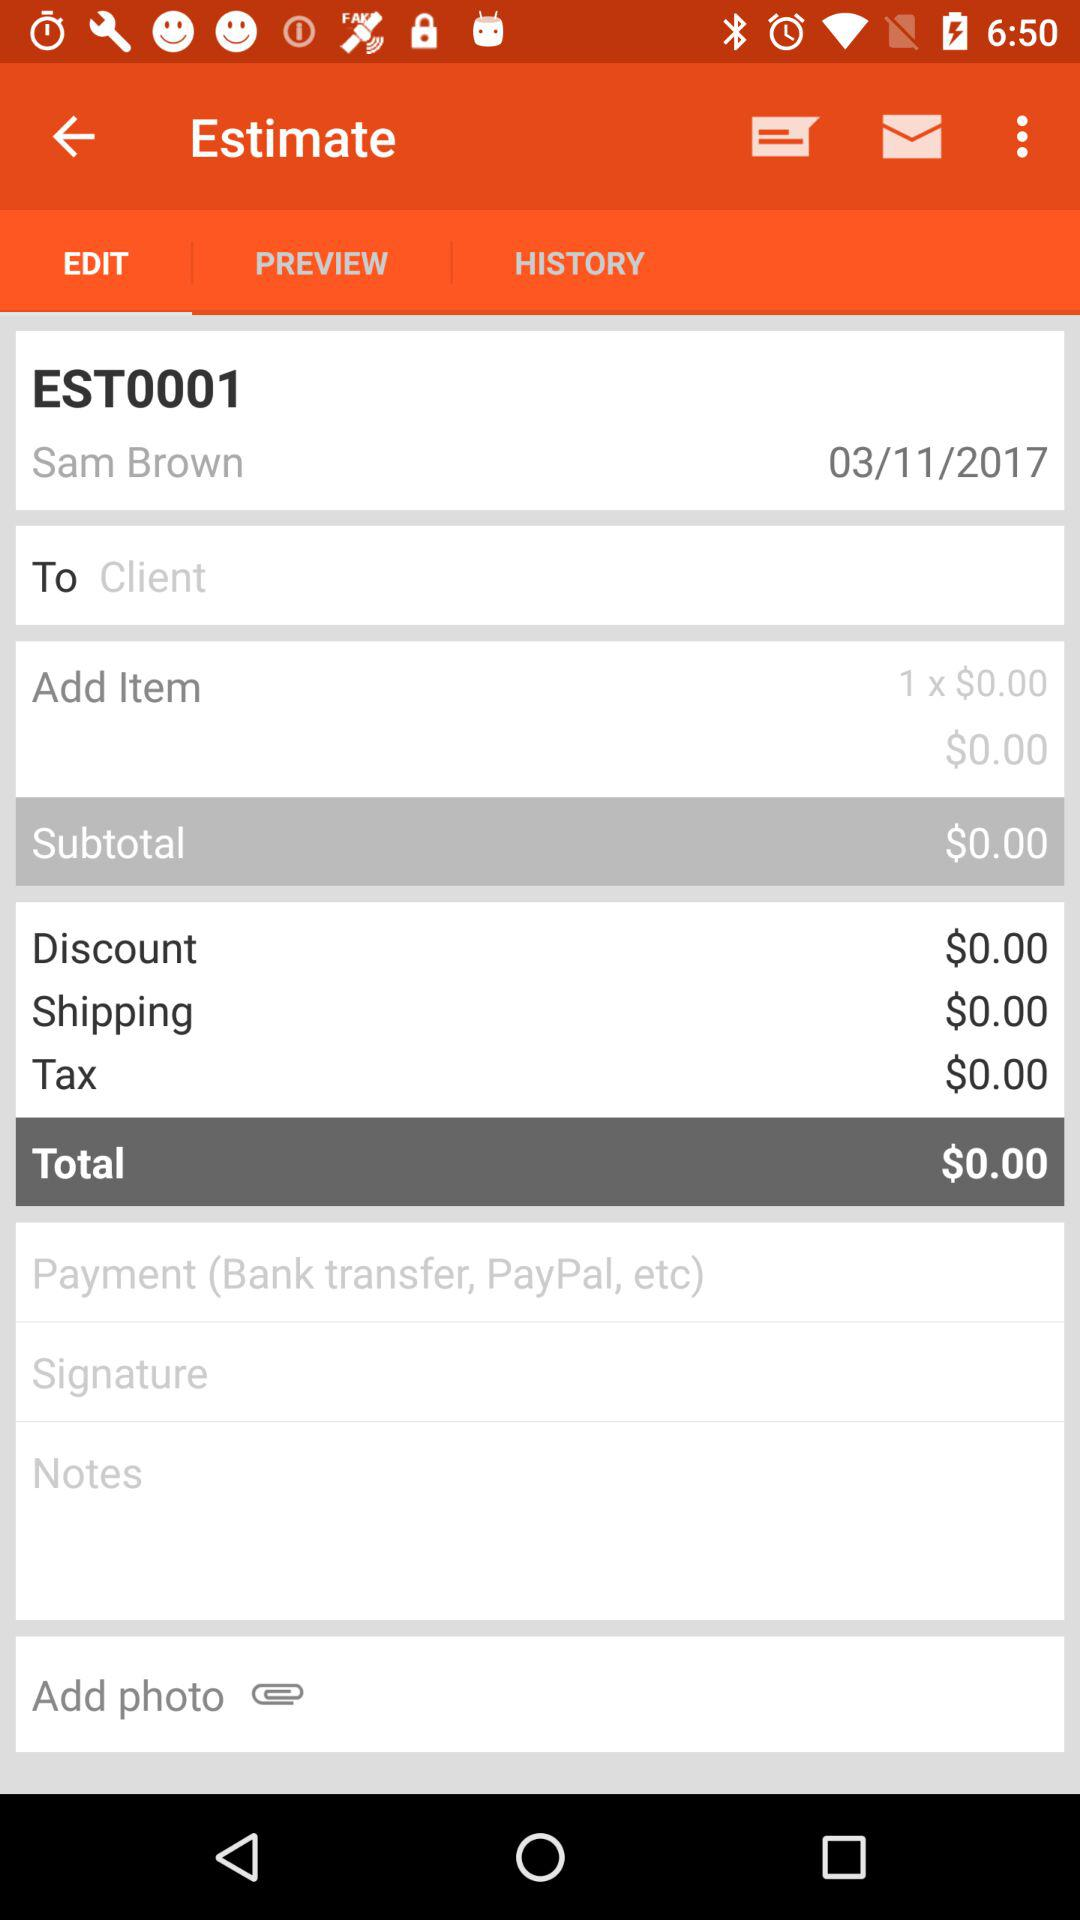Which tab has been selected? The tab that has been selected is "EDIT". 